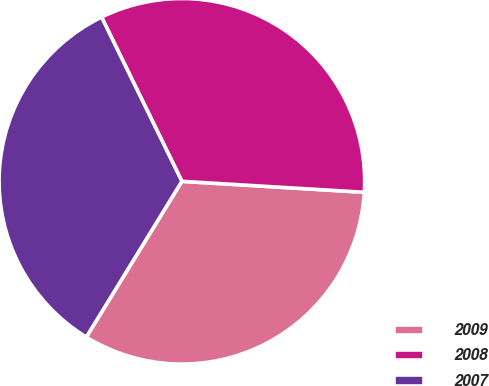Convert chart to OTSL. <chart><loc_0><loc_0><loc_500><loc_500><pie_chart><fcel>2009<fcel>2008<fcel>2007<nl><fcel>32.8%<fcel>33.2%<fcel>34.0%<nl></chart> 